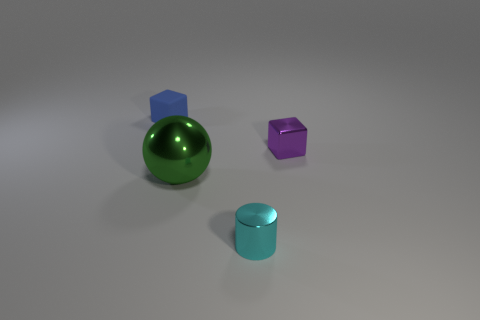The small cube behind the small cube that is to the right of the tiny object behind the purple thing is made of what material?
Your response must be concise. Rubber. Are there more tiny shiny cubes that are in front of the big green sphere than blue matte cubes in front of the tiny purple shiny object?
Provide a short and direct response. No. What number of cubes are either purple metallic objects or small blue rubber objects?
Provide a succinct answer. 2. There is a small cube that is on the left side of the tiny shiny object that is behind the green metallic ball; what number of small metallic cubes are on the left side of it?
Keep it short and to the point. 0. Are there more purple blocks than green cylinders?
Provide a short and direct response. Yes. Is the size of the green metal thing the same as the metallic block?
Your answer should be very brief. No. What number of objects are either tiny cyan things or tiny brown blocks?
Give a very brief answer. 1. There is a tiny object on the right side of the small shiny object in front of the small purple thing to the right of the cyan object; what is its shape?
Provide a short and direct response. Cube. Is the small thing left of the metallic sphere made of the same material as the cube that is right of the tiny blue rubber object?
Your response must be concise. No. What is the material of the other object that is the same shape as the tiny blue object?
Your response must be concise. Metal. 